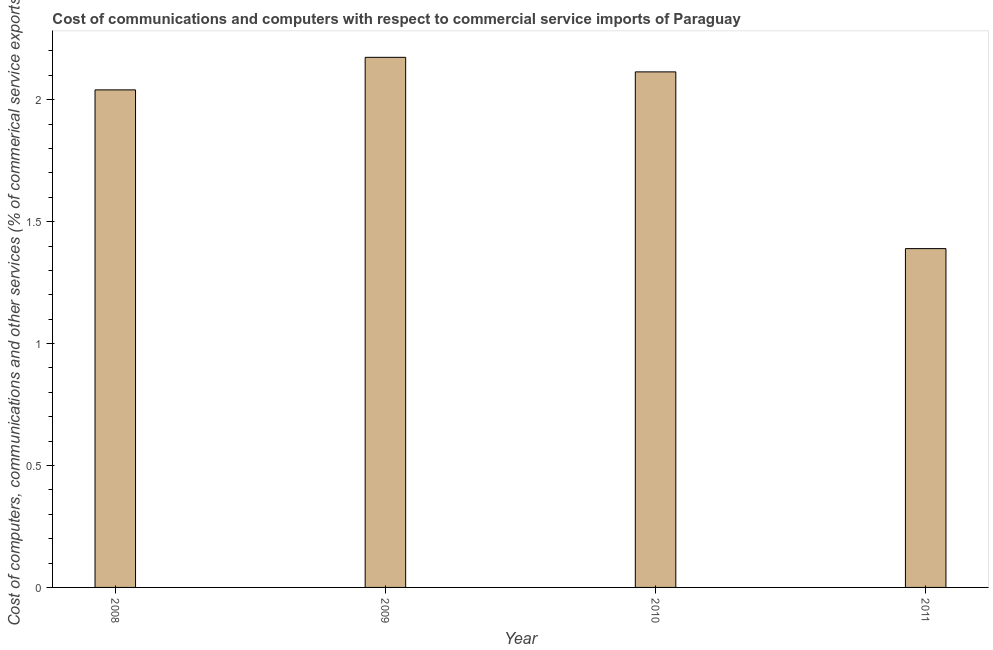Does the graph contain grids?
Provide a succinct answer. No. What is the title of the graph?
Keep it short and to the point. Cost of communications and computers with respect to commercial service imports of Paraguay. What is the label or title of the Y-axis?
Make the answer very short. Cost of computers, communications and other services (% of commerical service exports). What is the cost of communications in 2011?
Offer a very short reply. 1.39. Across all years, what is the maximum  computer and other services?
Keep it short and to the point. 2.17. Across all years, what is the minimum cost of communications?
Your answer should be very brief. 1.39. In which year was the cost of communications maximum?
Make the answer very short. 2009. In which year was the cost of communications minimum?
Your answer should be very brief. 2011. What is the sum of the cost of communications?
Provide a succinct answer. 7.72. What is the difference between the cost of communications in 2009 and 2011?
Give a very brief answer. 0.78. What is the average cost of communications per year?
Your answer should be compact. 1.93. What is the median cost of communications?
Your answer should be compact. 2.08. In how many years, is the  computer and other services greater than 1.2 %?
Keep it short and to the point. 4. What is the ratio of the cost of communications in 2008 to that in 2011?
Keep it short and to the point. 1.47. Is the sum of the cost of communications in 2008 and 2011 greater than the maximum cost of communications across all years?
Ensure brevity in your answer.  Yes. What is the difference between the highest and the lowest cost of communications?
Offer a very short reply. 0.78. What is the Cost of computers, communications and other services (% of commerical service exports) of 2008?
Your answer should be compact. 2.04. What is the Cost of computers, communications and other services (% of commerical service exports) in 2009?
Offer a very short reply. 2.17. What is the Cost of computers, communications and other services (% of commerical service exports) of 2010?
Your answer should be very brief. 2.11. What is the Cost of computers, communications and other services (% of commerical service exports) of 2011?
Provide a succinct answer. 1.39. What is the difference between the Cost of computers, communications and other services (% of commerical service exports) in 2008 and 2009?
Your answer should be very brief. -0.13. What is the difference between the Cost of computers, communications and other services (% of commerical service exports) in 2008 and 2010?
Provide a succinct answer. -0.07. What is the difference between the Cost of computers, communications and other services (% of commerical service exports) in 2008 and 2011?
Give a very brief answer. 0.65. What is the difference between the Cost of computers, communications and other services (% of commerical service exports) in 2009 and 2010?
Offer a very short reply. 0.06. What is the difference between the Cost of computers, communications and other services (% of commerical service exports) in 2009 and 2011?
Offer a terse response. 0.78. What is the difference between the Cost of computers, communications and other services (% of commerical service exports) in 2010 and 2011?
Offer a very short reply. 0.72. What is the ratio of the Cost of computers, communications and other services (% of commerical service exports) in 2008 to that in 2009?
Make the answer very short. 0.94. What is the ratio of the Cost of computers, communications and other services (% of commerical service exports) in 2008 to that in 2010?
Your answer should be very brief. 0.96. What is the ratio of the Cost of computers, communications and other services (% of commerical service exports) in 2008 to that in 2011?
Provide a short and direct response. 1.47. What is the ratio of the Cost of computers, communications and other services (% of commerical service exports) in 2009 to that in 2010?
Keep it short and to the point. 1.03. What is the ratio of the Cost of computers, communications and other services (% of commerical service exports) in 2009 to that in 2011?
Your response must be concise. 1.56. What is the ratio of the Cost of computers, communications and other services (% of commerical service exports) in 2010 to that in 2011?
Give a very brief answer. 1.52. 